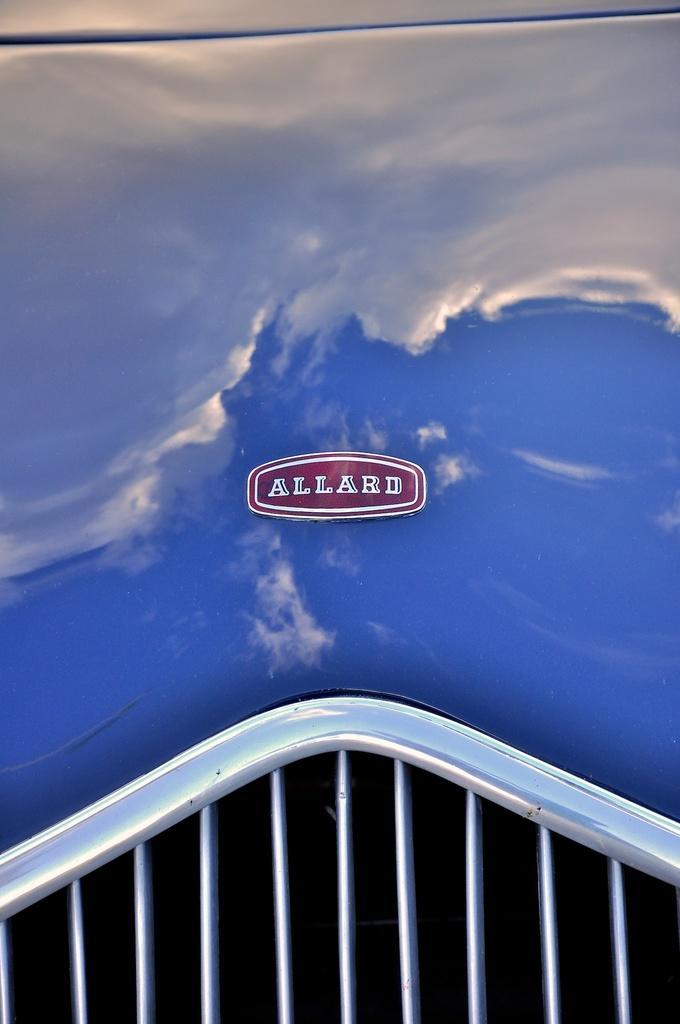How would you summarize this image in a sentence or two? In this image, we can see front view of a car which is in blue color. 